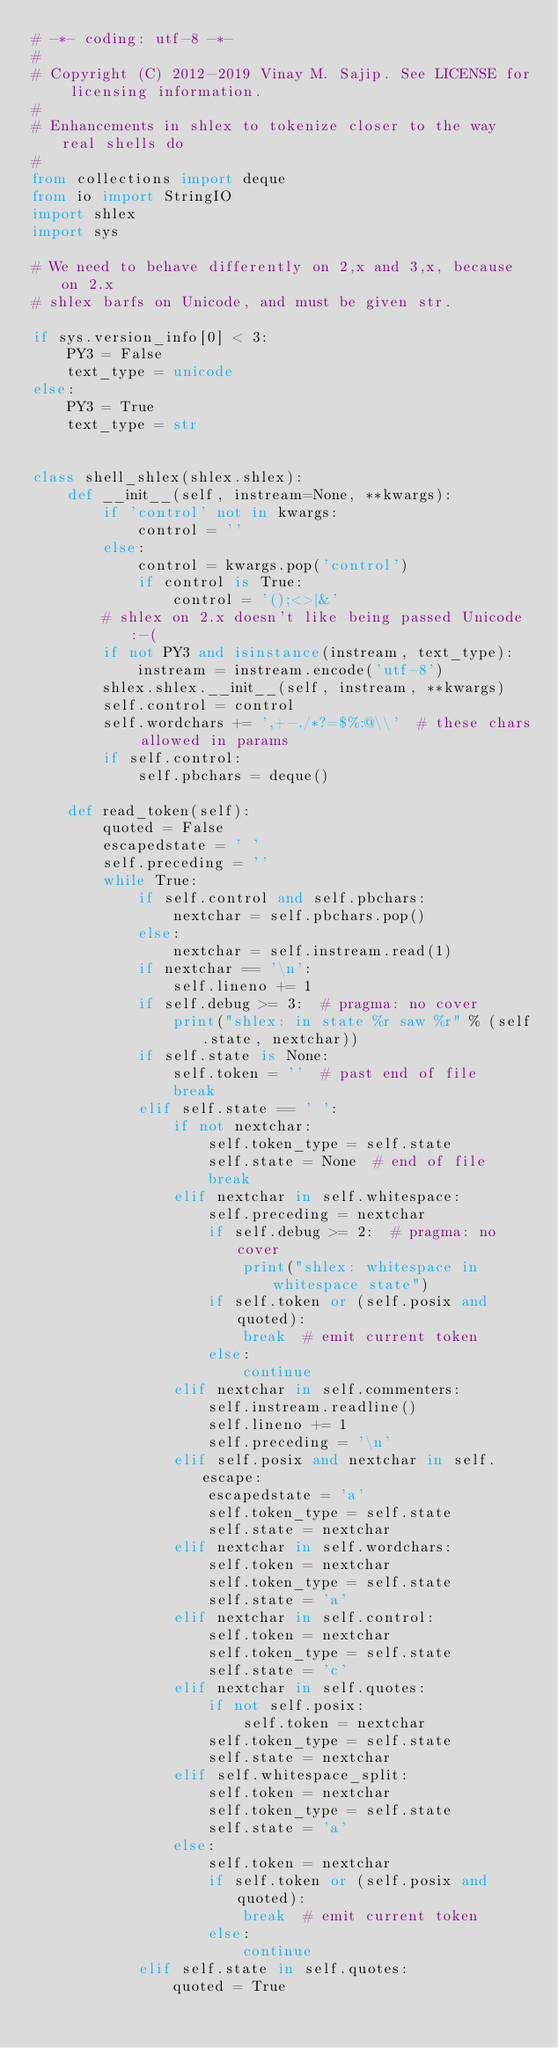<code> <loc_0><loc_0><loc_500><loc_500><_Python_># -*- coding: utf-8 -*-
#
# Copyright (C) 2012-2019 Vinay M. Sajip. See LICENSE for licensing information.
#
# Enhancements in shlex to tokenize closer to the way real shells do
#
from collections import deque
from io import StringIO
import shlex
import sys

# We need to behave differently on 2,x and 3,x, because on 2.x
# shlex barfs on Unicode, and must be given str.

if sys.version_info[0] < 3:
    PY3 = False
    text_type = unicode
else:
    PY3 = True
    text_type = str


class shell_shlex(shlex.shlex):
    def __init__(self, instream=None, **kwargs):
        if 'control' not in kwargs:
            control = ''
        else:
            control = kwargs.pop('control')
            if control is True:
                control = '();<>|&'
        # shlex on 2.x doesn't like being passed Unicode :-(
        if not PY3 and isinstance(instream, text_type):
            instream = instream.encode('utf-8')
        shlex.shlex.__init__(self, instream, **kwargs)
        self.control = control
        self.wordchars += ',+-./*?=$%:@\\'  # these chars allowed in params
        if self.control:
            self.pbchars = deque()

    def read_token(self):
        quoted = False
        escapedstate = ' '
        self.preceding = ''
        while True:
            if self.control and self.pbchars:
                nextchar = self.pbchars.pop()
            else:
                nextchar = self.instream.read(1)
            if nextchar == '\n':
                self.lineno += 1
            if self.debug >= 3:  # pragma: no cover
                print("shlex: in state %r saw %r" % (self.state, nextchar))
            if self.state is None:
                self.token = ''  # past end of file
                break
            elif self.state == ' ':
                if not nextchar:
                    self.token_type = self.state
                    self.state = None  # end of file
                    break
                elif nextchar in self.whitespace:
                    self.preceding = nextchar
                    if self.debug >= 2:  # pragma: no cover
                        print("shlex: whitespace in whitespace state")
                    if self.token or (self.posix and quoted):
                        break  # emit current token
                    else:
                        continue
                elif nextchar in self.commenters:
                    self.instream.readline()
                    self.lineno += 1
                    self.preceding = '\n'
                elif self.posix and nextchar in self.escape:
                    escapedstate = 'a'
                    self.token_type = self.state
                    self.state = nextchar
                elif nextchar in self.wordchars:
                    self.token = nextchar
                    self.token_type = self.state
                    self.state = 'a'
                elif nextchar in self.control:
                    self.token = nextchar
                    self.token_type = self.state
                    self.state = 'c'
                elif nextchar in self.quotes:
                    if not self.posix:
                        self.token = nextchar
                    self.token_type = self.state
                    self.state = nextchar
                elif self.whitespace_split:
                    self.token = nextchar
                    self.token_type = self.state
                    self.state = 'a'
                else:
                    self.token = nextchar
                    if self.token or (self.posix and quoted):
                        break  # emit current token
                    else:
                        continue
            elif self.state in self.quotes:
                quoted = True</code> 